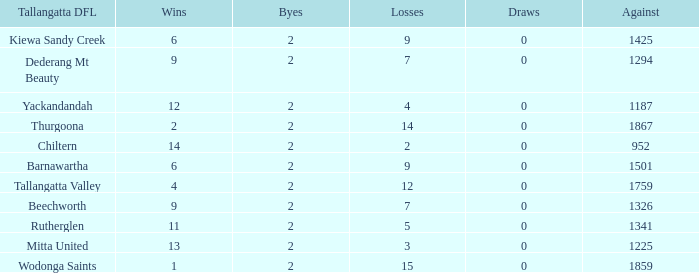What are the draws when wins are fwewer than 9 and byes fewer than 2? 0.0. 